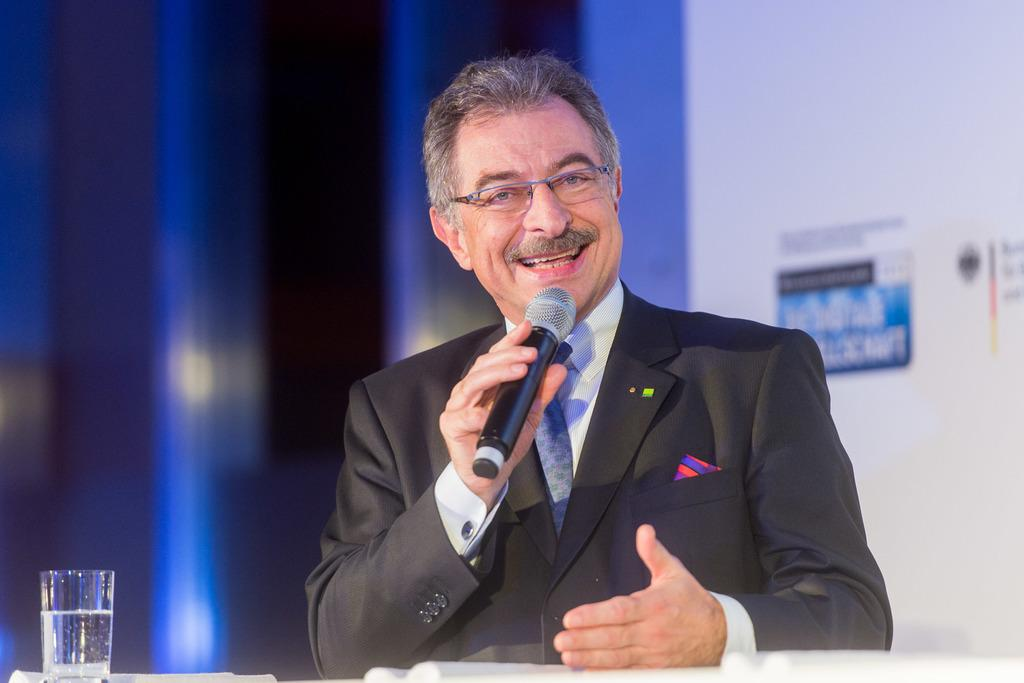What is the person in the image wearing on their upper body? The person is wearing a black jacket. What accessory is the person wearing on their face? The person is wearing spectacles. What is the person holding in their left hand? The person is holding a mic in their left hand. What can be seen behind the person in the image? The person is standing in front of a desk. What is present on the desk in the image? There is a glass on the desk. What type of ants can be seen crawling on the person's jacket in the image? There are no ants visible on the person's jacket in the image. What musical instrument is the person playing in the image? The person is not playing any musical instrument in the image; they are holding a mic. 